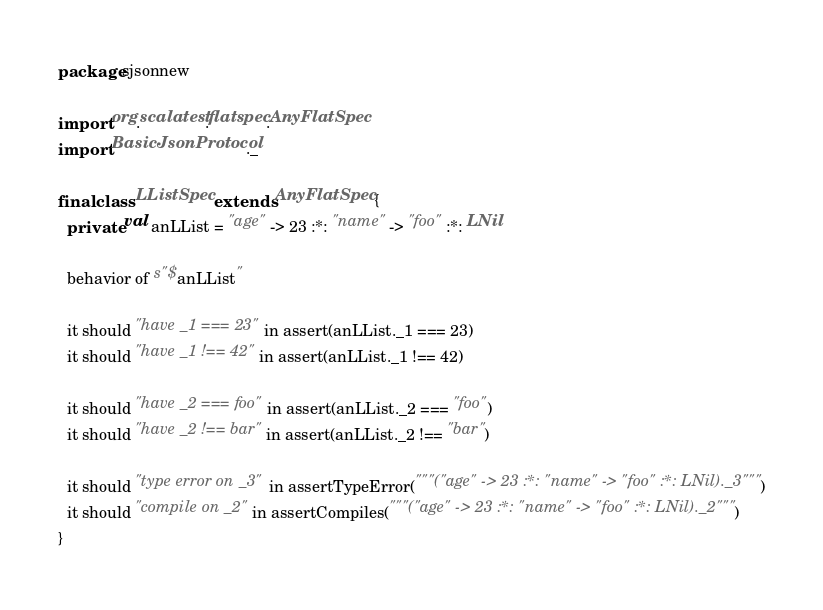Convert code to text. <code><loc_0><loc_0><loc_500><loc_500><_Scala_>package sjsonnew

import org.scalatest.flatspec.AnyFlatSpec
import BasicJsonProtocol._

final class LListSpec extends AnyFlatSpec {
  private val anLList = "age" -> 23 :*: "name" -> "foo" :*: LNil

  behavior of s"$anLList"

  it should "have _1 === 23" in assert(anLList._1 === 23)
  it should "have _1 !== 42" in assert(anLList._1 !== 42)

  it should "have _2 === foo" in assert(anLList._2 === "foo")
  it should "have _2 !== bar" in assert(anLList._2 !== "bar")

  it should "type error on _3" in assertTypeError("""("age" -> 23 :*: "name" -> "foo" :*: LNil)._3""")
  it should "compile on _2" in assertCompiles("""("age" -> 23 :*: "name" -> "foo" :*: LNil)._2""")
}
</code> 